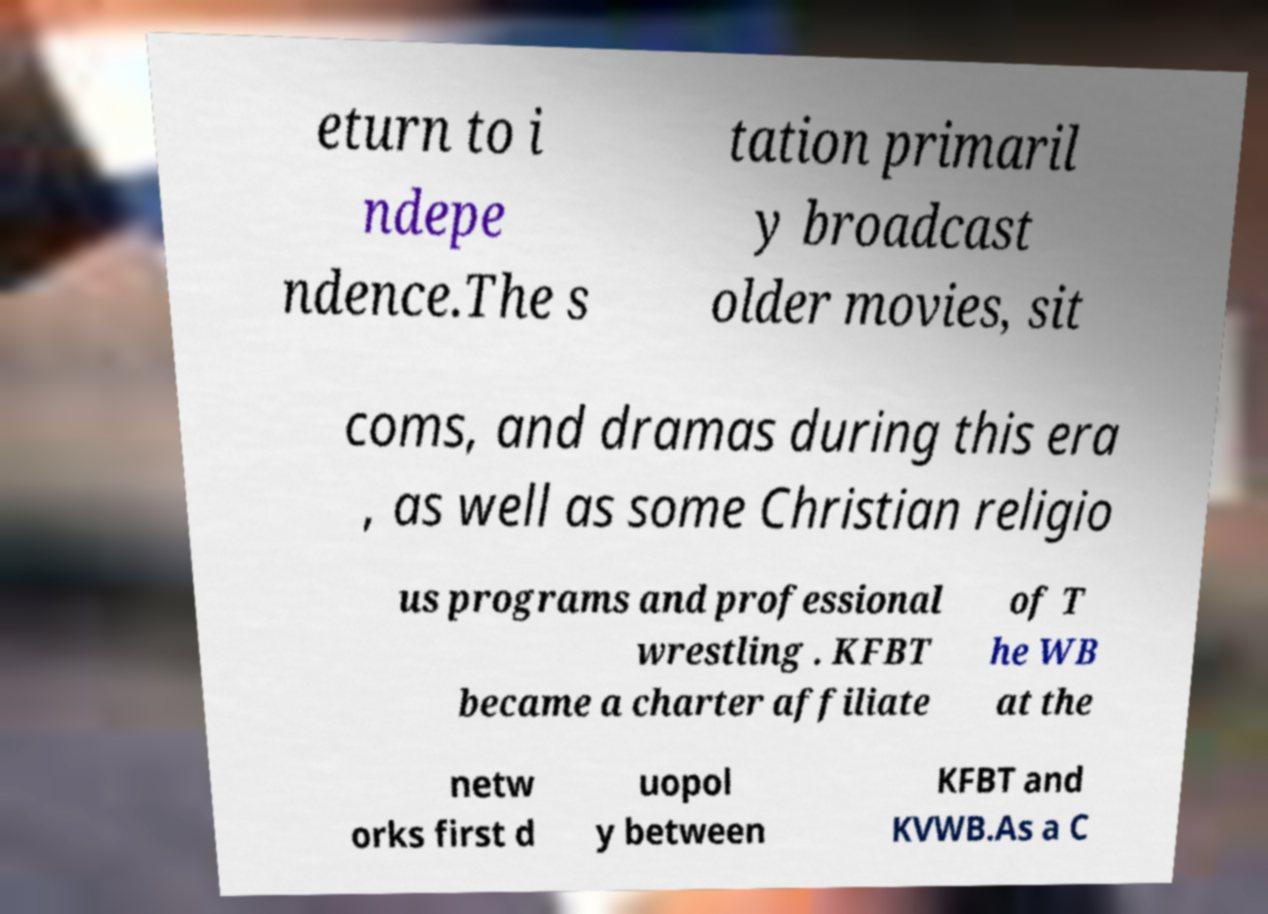There's text embedded in this image that I need extracted. Can you transcribe it verbatim? eturn to i ndepe ndence.The s tation primaril y broadcast older movies, sit coms, and dramas during this era , as well as some Christian religio us programs and professional wrestling . KFBT became a charter affiliate of T he WB at the netw orks first d uopol y between KFBT and KVWB.As a C 